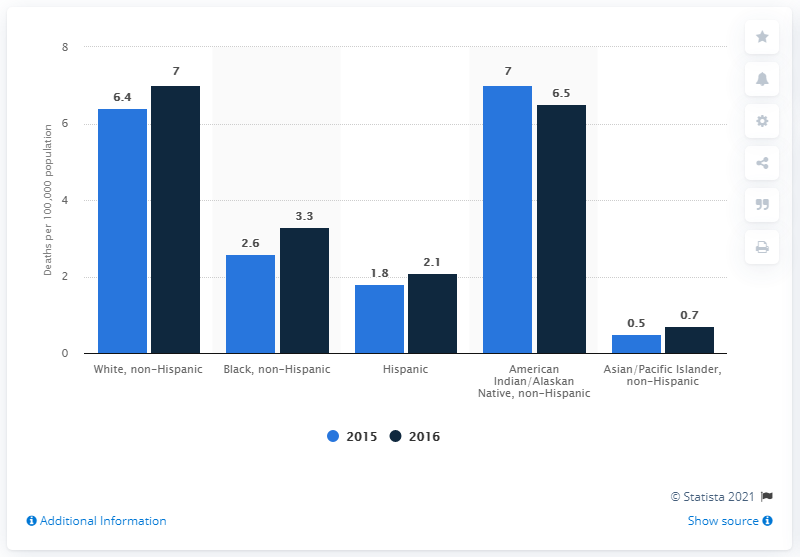Point out several critical features in this image. The chart shows that at least one race experiences a decrease in death rates. According to data from 2016, the race with the highest death rate is white, non-Hispanic. 